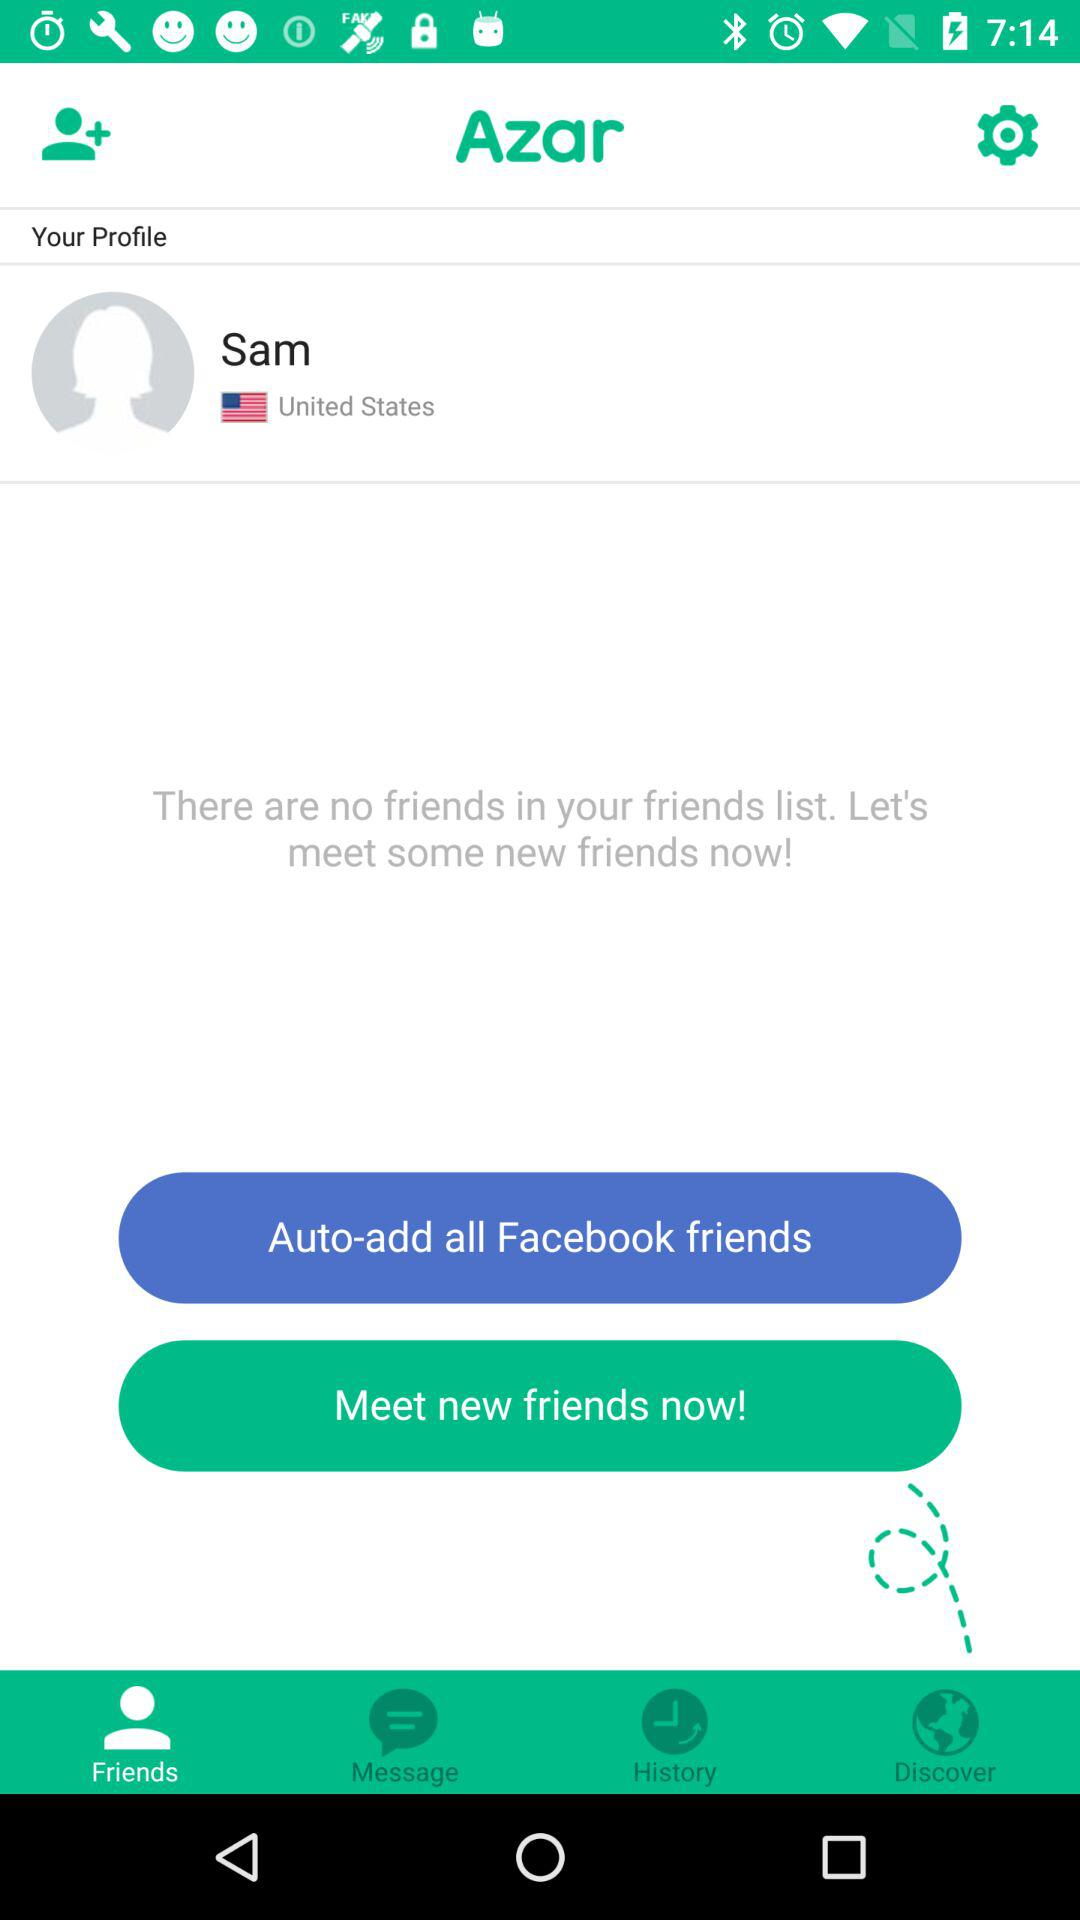How many friends do you have?
Answer the question using a single word or phrase. 0 